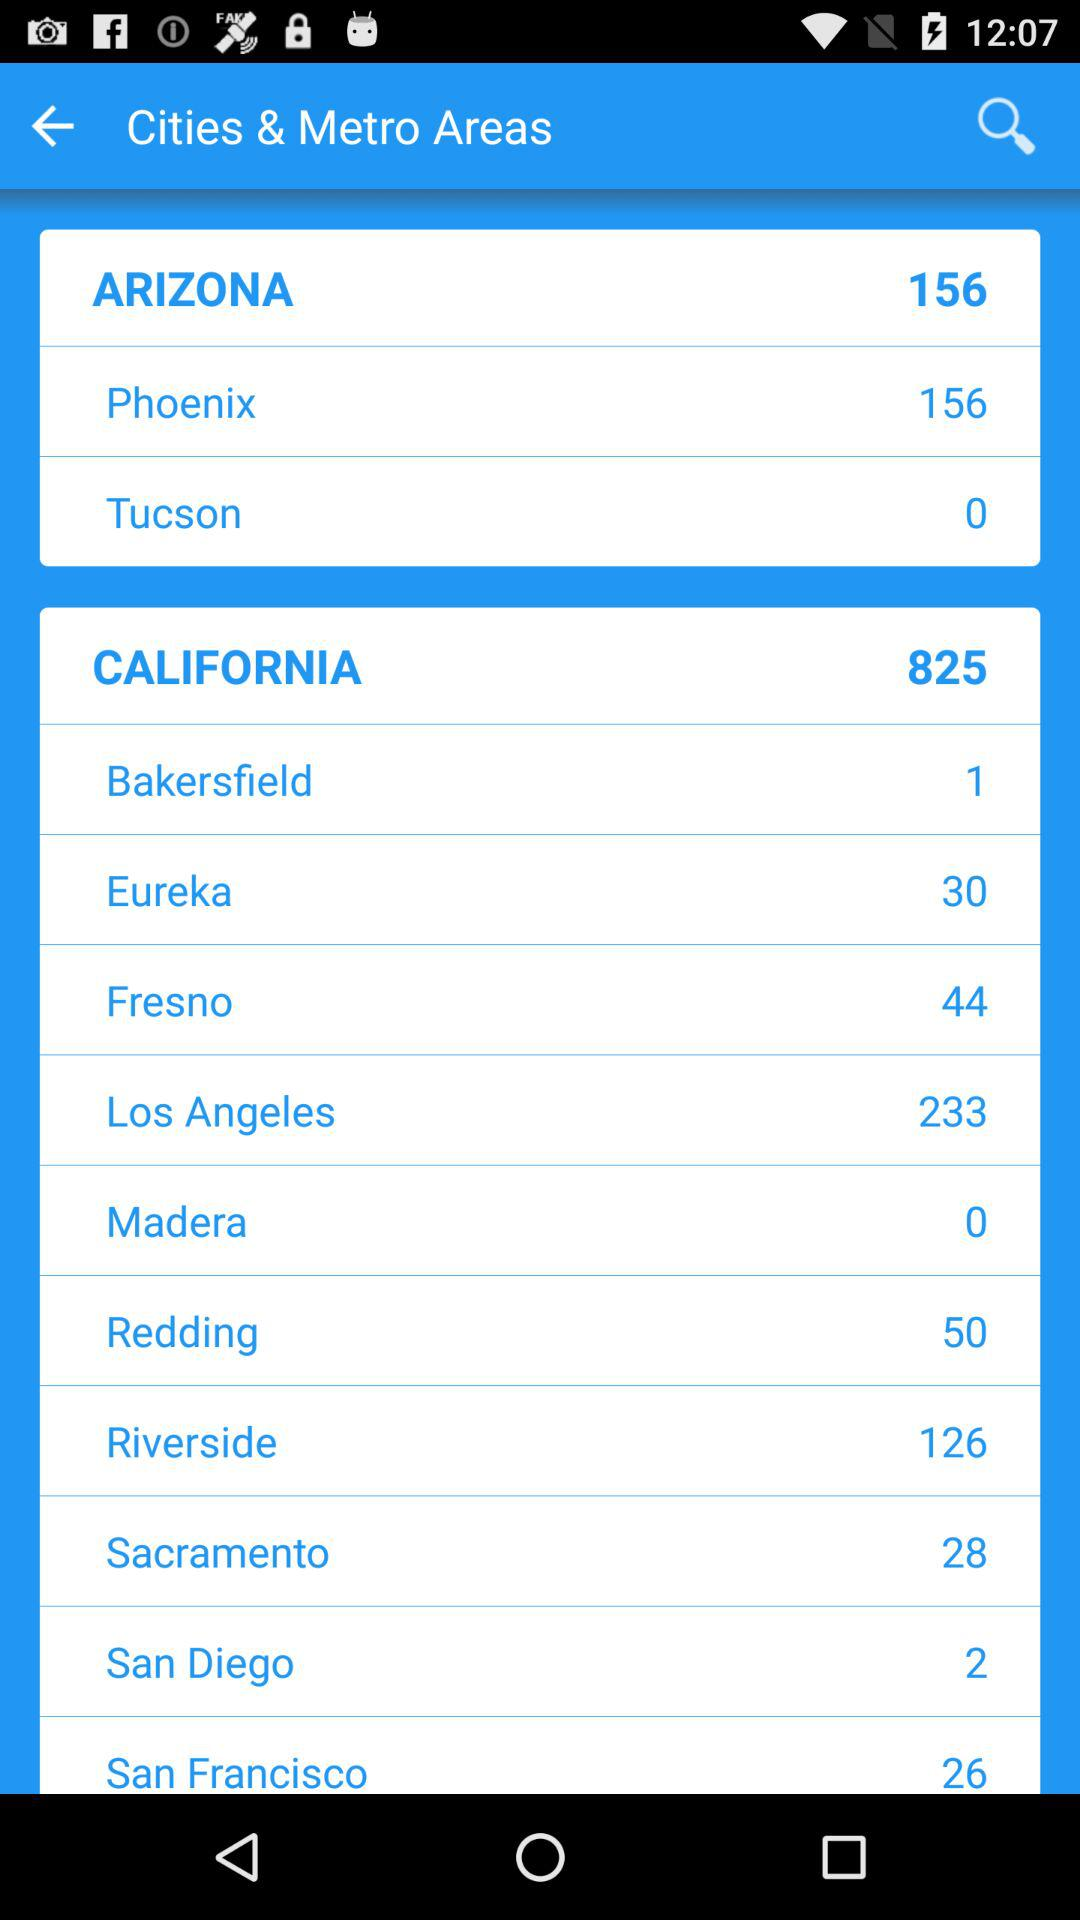How many areas are there in Arizona? There are 156 areas in Arizona. 